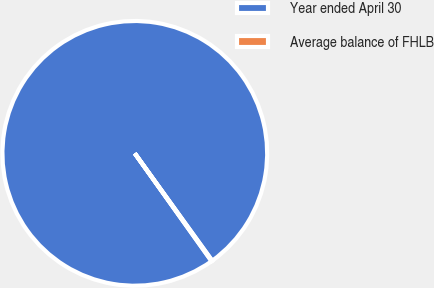<chart> <loc_0><loc_0><loc_500><loc_500><pie_chart><fcel>Year ended April 30<fcel>Average balance of FHLB<nl><fcel>99.9%<fcel>0.1%<nl></chart> 